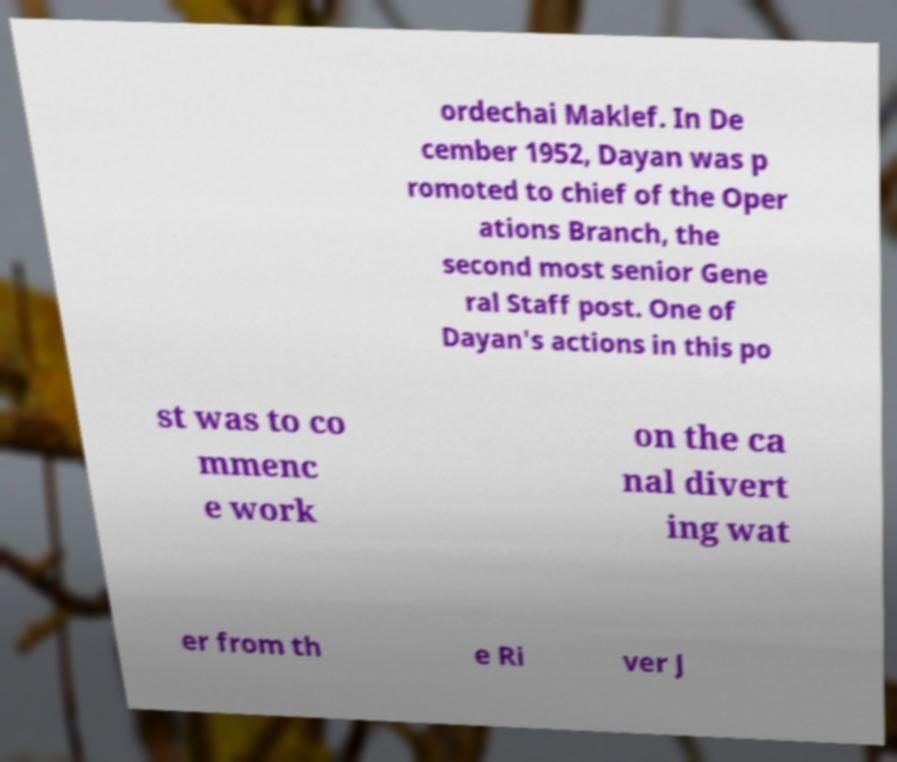Please read and relay the text visible in this image. What does it say? ordechai Maklef. In De cember 1952, Dayan was p romoted to chief of the Oper ations Branch, the second most senior Gene ral Staff post. One of Dayan's actions in this po st was to co mmenc e work on the ca nal divert ing wat er from th e Ri ver J 